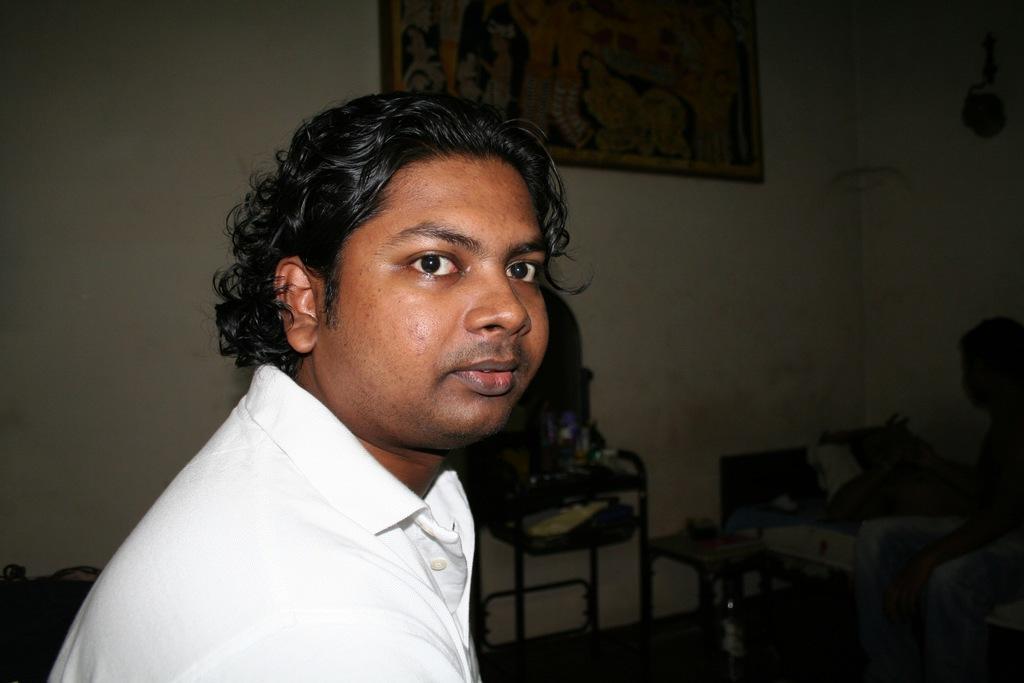How would you summarize this image in a sentence or two? In the foreground of this image, there is a man. In the background, there are few objects on the table and a man sitting and a man lying on the bed, a frame and an object on the wall. 